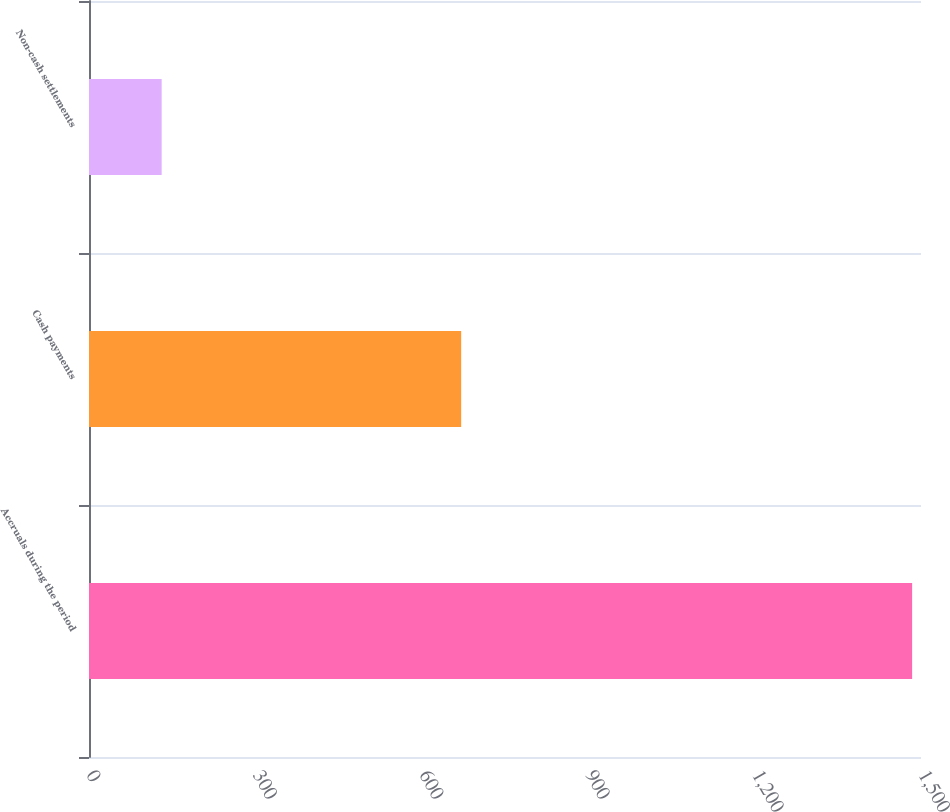Convert chart to OTSL. <chart><loc_0><loc_0><loc_500><loc_500><bar_chart><fcel>Accruals during the period<fcel>Cash payments<fcel>Non-cash settlements<nl><fcel>1484<fcel>671<fcel>131<nl></chart> 